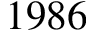<formula> <loc_0><loc_0><loc_500><loc_500>1 9 8 6</formula> 